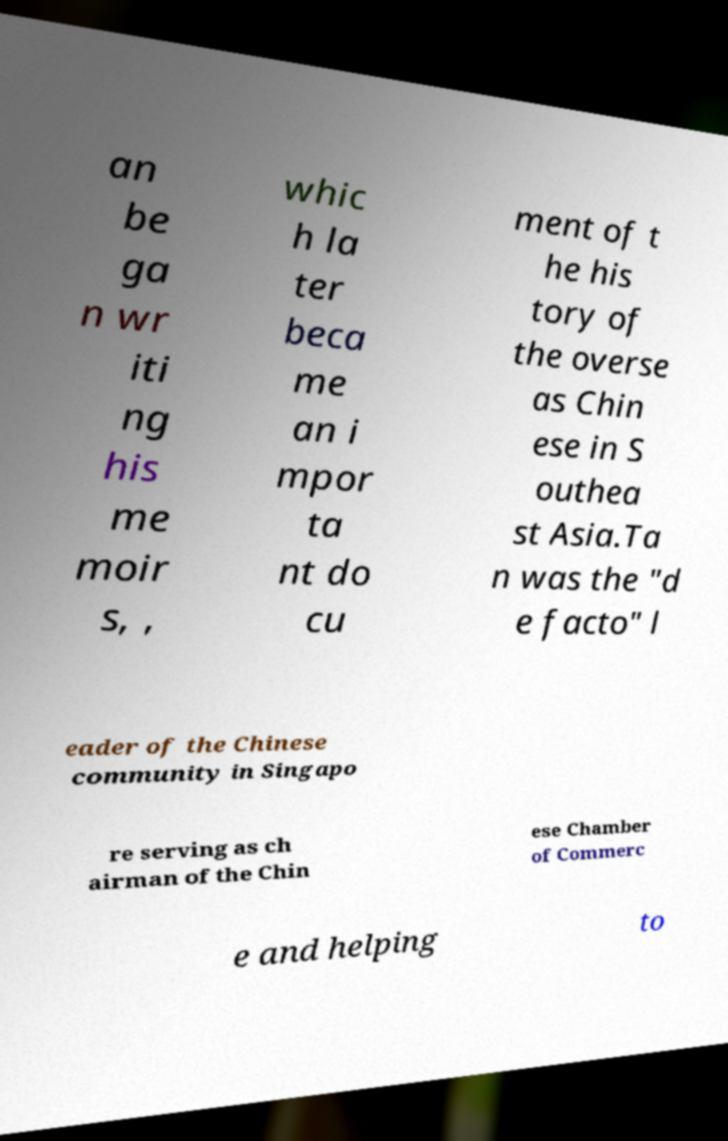What messages or text are displayed in this image? I need them in a readable, typed format. an be ga n wr iti ng his me moir s, , whic h la ter beca me an i mpor ta nt do cu ment of t he his tory of the overse as Chin ese in S outhea st Asia.Ta n was the "d e facto" l eader of the Chinese community in Singapo re serving as ch airman of the Chin ese Chamber of Commerc e and helping to 